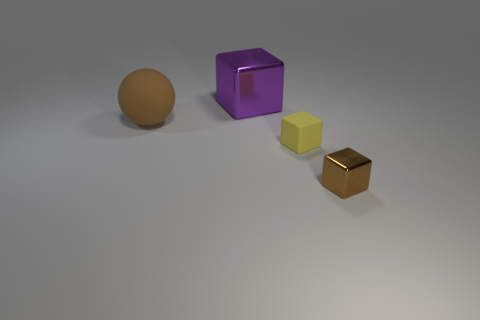Add 4 large cylinders. How many objects exist? 8 Subtract all spheres. How many objects are left? 3 Subtract 0 blue balls. How many objects are left? 4 Subtract all brown balls. Subtract all yellow rubber objects. How many objects are left? 2 Add 1 small rubber cubes. How many small rubber cubes are left? 2 Add 1 yellow matte objects. How many yellow matte objects exist? 2 